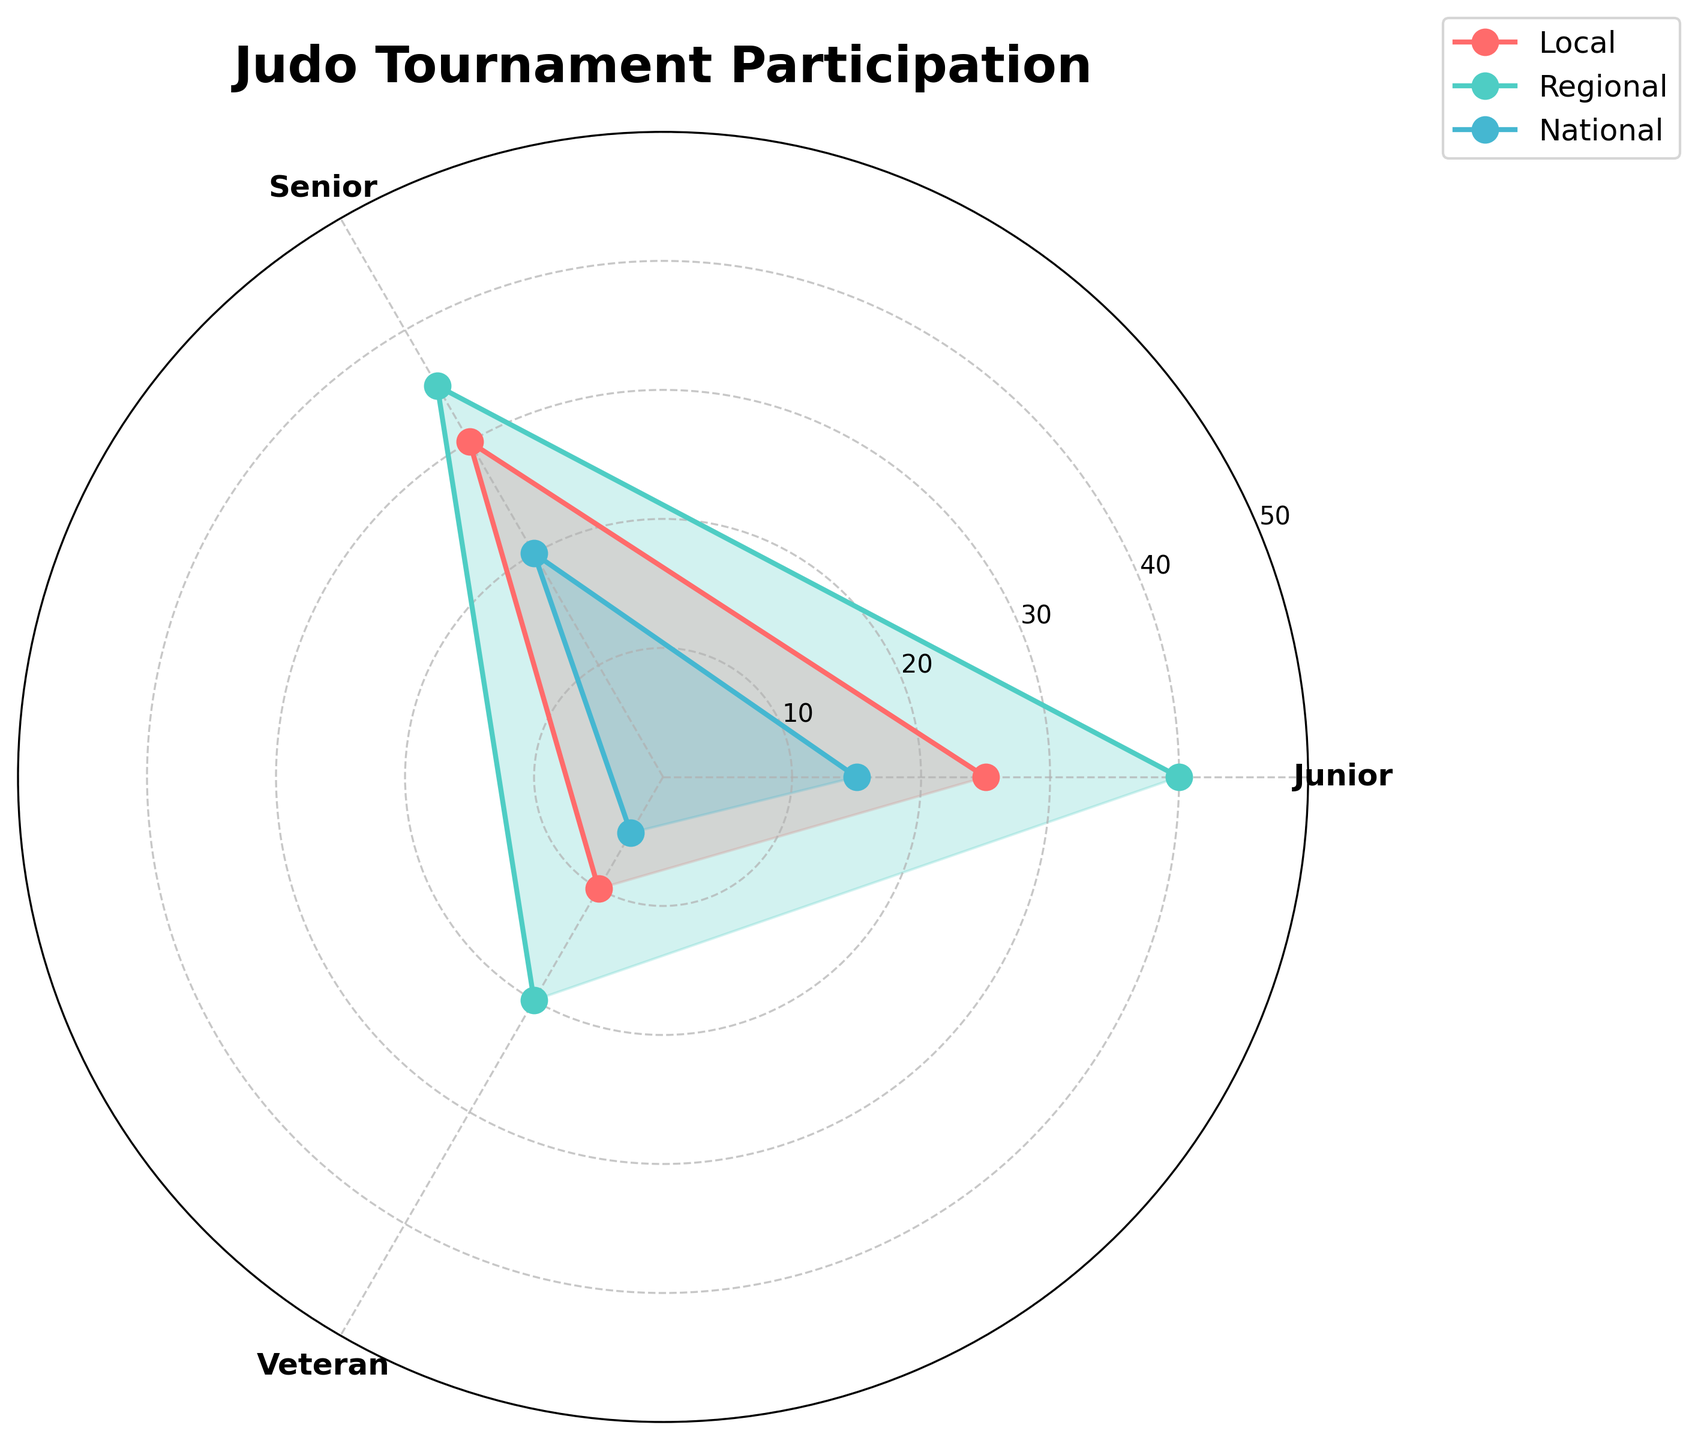Which group has the highest participation rate in local tournaments? The figure shows the "Local Tournaments" participation rate for Junior, Senior, and Veteran categories plotted as lines on a polar plot. By examining the lengths of these lines, we see that the Senior category has the highest value of 30.
Answer: Senior What is the total participation rate for regional tournaments across all groups? The Regional participation rates for Junior, Senior, and Veteran categories are 40, 35, and 20, respectively. Adding these values together: 40 + 35 + 20.
Answer: 95 How does the participation rate for veterans in national tournaments compare to seniors in the same category? The participation rate for Veterans in national tournaments is 5 and for Seniors, it is 20. Comparatively, 5 is lower than 20.
Answer: Veterans have lower participation What is the average participation rate for juniors across all tournament types? For Juniors, the participation rates are 25, 40, and 15. Sum these values: 25 + 40 + 15 = 80. Then divide by 3.
Answer: 26.67 Which category has the highest overall participation in national tournaments? The participation rates in national tournaments are given for Junior, Senior, and Veteran categories as 15, 20, and 5, respectively. The highest value is for Seniors.
Answer: Senior Is the participation rate for senior judo players in local tournaments greater than the participation rate for junior judo players in regional tournaments? The participation rate for senior players in local tournaments is 30, and for junior players in regional tournaments is 40. 30 is less than 40.
Answer: No What is the participation rate range for local tournaments? The local tournament participation rates are 25 for Juniors, 30 for Seniors, and 10 for Veterans. The range is the difference between the maximum (30) and minimum (10) values: 30 - 10.
Answer: 20 By how much does the participation rate for juniors in regional tournaments exceed their participation rate in national tournaments? The participation rates for Junior players are 40 in regional tournaments and 15 in national tournaments. The difference is: 40 - 15.
Answer: 25 Which category shows the highest variability in tournament participation rates? By examining the differences between maximum and minimum participation rates for each category: Juniors (40-15=25), Seniors (35-20=15), and Veterans (20-5=15). Junior shows the highest variability.
Answer: Junior What is the median participation rate for seniors in all types of tournaments? The participation rates for Seniors are 30 (Local), 35 (Regional), and 20 (National). The median is the middle value when sorted: 20, 30, 35.
Answer: 30 